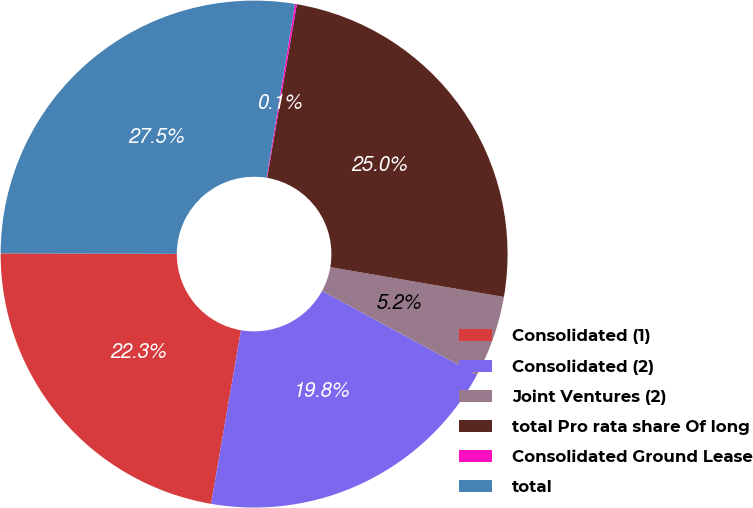Convert chart. <chart><loc_0><loc_0><loc_500><loc_500><pie_chart><fcel>Consolidated (1)<fcel>Consolidated (2)<fcel>Joint Ventures (2)<fcel>total Pro rata share Of long<fcel>Consolidated Ground Lease<fcel>total<nl><fcel>22.33%<fcel>19.81%<fcel>5.2%<fcel>25.01%<fcel>0.12%<fcel>27.53%<nl></chart> 